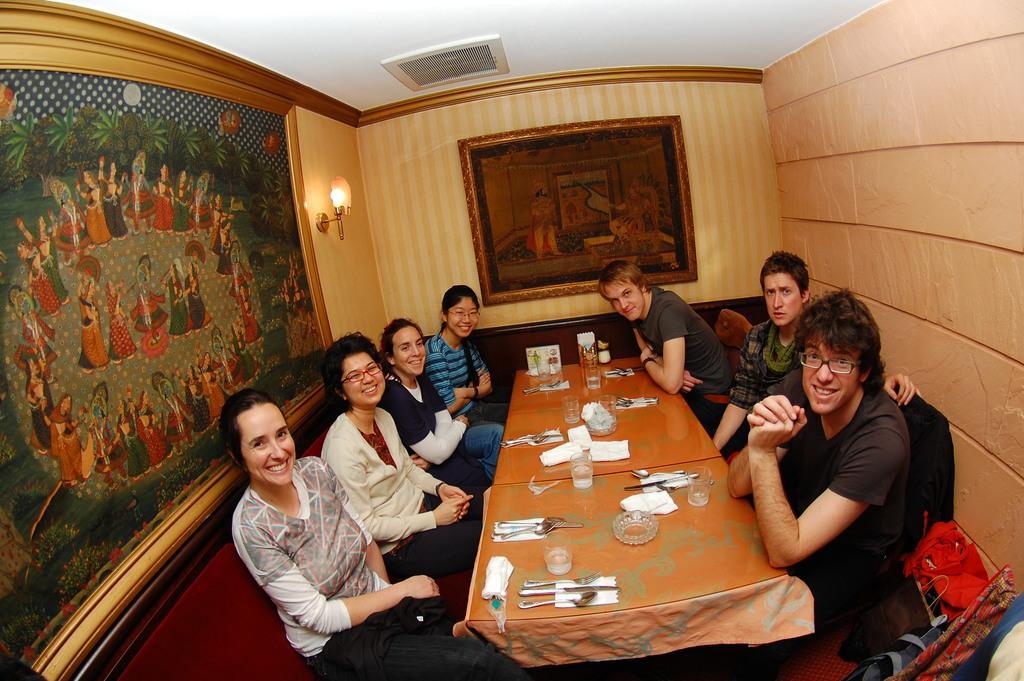How would you summarize this image in a sentence or two? In this image i can see inside view of a room and there is a wall on the right side and on the middle a photo frame attached to the wall , left side there is a lamp attached to the wall , and there are the persons sitting around the table and on the table there is a bowl, there is a glass and there's a paper ,spoons kept on the table. And all the persons sitting on the chair they are smiling. 